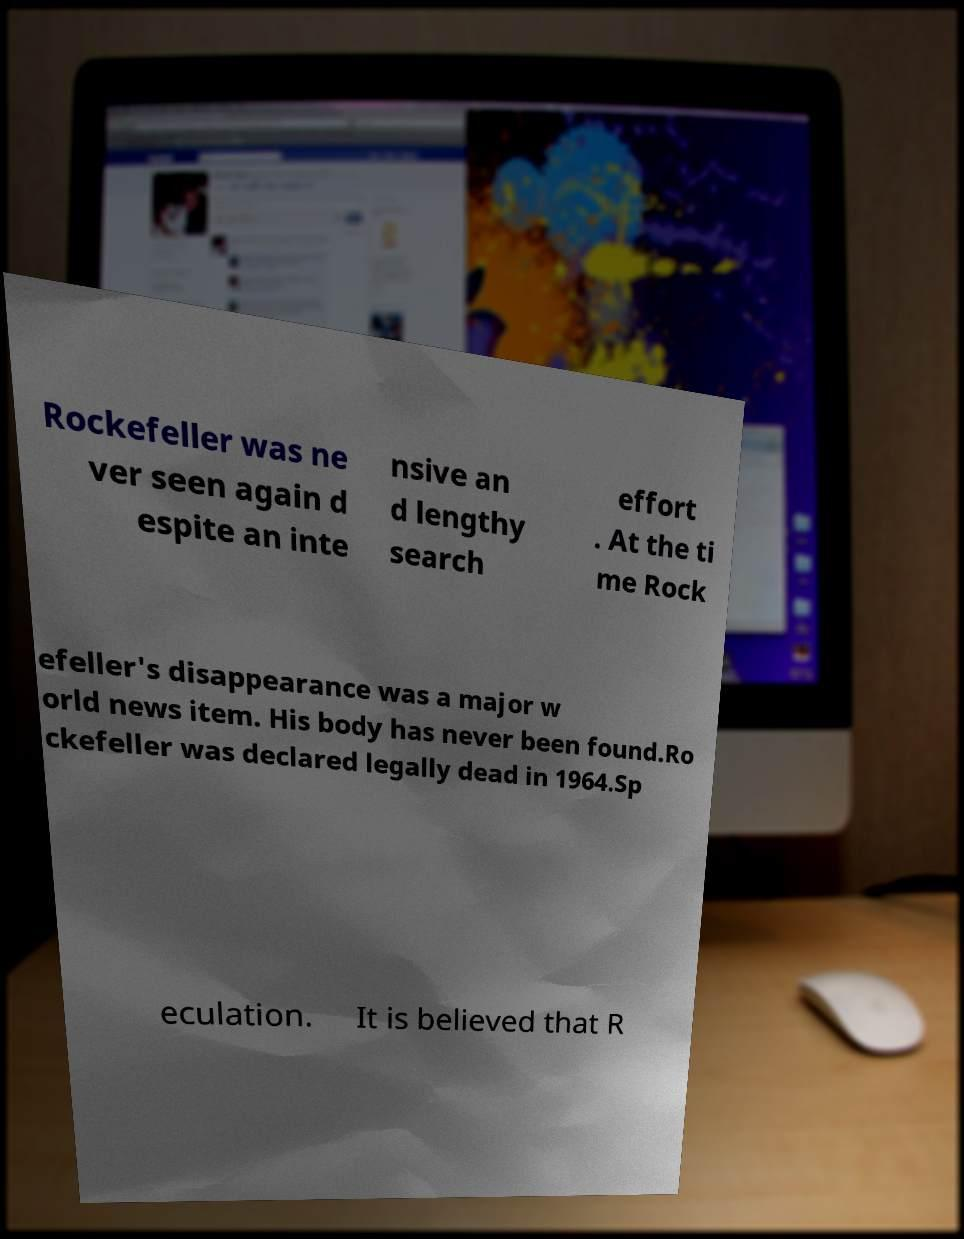Can you read and provide the text displayed in the image?This photo seems to have some interesting text. Can you extract and type it out for me? Rockefeller was ne ver seen again d espite an inte nsive an d lengthy search effort . At the ti me Rock efeller's disappearance was a major w orld news item. His body has never been found.Ro ckefeller was declared legally dead in 1964.Sp eculation. It is believed that R 